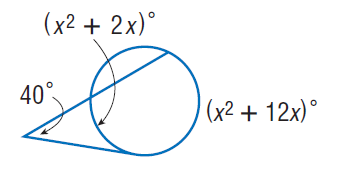Answer the mathemtical geometry problem and directly provide the correct option letter.
Question: Find x. Assume that any segment that appears to be tangent is tangent.
Choices: A: 8 B: 40 C: 80 D: 160 A 